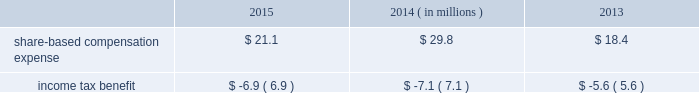During fiscal 2013 , we entered into an asr with a financial institution to repurchase an aggregate of $ 125 million of our common stock .
In exchange for an up-front payment of $ 125 million , the financial institution committed to deliver a number of shares during the asr 2019s purchase period , which ended on march 30 , 2013 .
The total number of shares delivered under this asr was 2.5 million at an average price of $ 49.13 per share .
During fiscal 2013 , in addition to shares repurchased under the asr , we repurchased and retired 1.1 million shares of our common stock at a cost of $ 50.3 million , or an average of $ 44.55 per share , including commissions .
Note 10 2014share-based awards and options non-qualified stock options and restricted stock have been granted to officers , key employees and directors under the global payments inc .
2000 long-term incentive plan , as amended and restated ( the 201c2000 plan 201d ) , the global payments inc .
Amended and restated 2005 incentive plan ( the 201c2005 plan 201d ) , the amended and restated 2000 non-employee director stock option plan ( the 201cdirector stock option plan 201d ) , and the global payments inc .
2011 incentive plan ( the 201c2011 plan 201d ) ( collectively , the 201cplans 201d ) .
There were no further grants made under the 2000 plan after the 2005 plan was effective , and the director stock option plan expired by its terms on february 1 , 2011 .
There will be no future grants under the 2000 plan , the 2005 plan or the director stock option the 2011 plan permits grants of equity to employees , officers , directors and consultants .
A total of 7.0 million shares of our common stock was reserved and made available for issuance pursuant to awards granted under the 2011 plan .
The table summarizes share-based compensation expense and the related income tax benefit recognized for stock options , restricted stock , performance units , tsr units , and shares issued under our employee stock purchase plan ( each as described below ) .
2015 2014 2013 ( in millions ) .
We grant various share-based awards pursuant to the plans under what we refer to as our 201clong-term incentive plan . 201d the awards are held in escrow and released upon the grantee 2019s satisfaction of conditions of the award certificate .
Restricted stock and restricted stock units we grant restricted stock and restricted stock units .
Restricted stock awards vest over a period of time , provided , however , that if the grantee is not employed by us on the vesting date , the shares are forfeited .
Restricted shares cannot be sold or transferred until they have vested .
Restricted stock granted before fiscal 2015 vests in equal installments on each of the first four anniversaries of the grant date .
Restricted stock granted during fiscal 2015 will either vest in equal installments on each of the first three anniversaries of the grant date or cliff vest at the end of a three-year service period .
The grant date fair value of restricted stock , which is based on the quoted market value of our common stock at the closing of the award date , is recognized as share-based compensation expense on a straight-line basis over the vesting period .
Performance units certain of our executives have been granted up to three types of performance units under our long-term incentive plan .
Performance units are performance-based restricted stock units that , after a performance period , convert into common shares , which may be restricted .
The number of shares is dependent upon the achievement of certain performance measures during the performance period .
The target number of performance units and any market-based performance measures ( 201cat threshold , 201d 201ctarget , 201d and 201cmaximum 201d ) are set by the compensation committee of our board of directors .
Performance units are converted only after the compensation committee certifies performance based on pre-established goals .
80 2013 global payments inc .
| 2015 form 10-k annual report .
What was the total income tax benefit that came from buying back their common stock from 2013 to 2015? 
Rationale: to calculate the income tax benefit one would need to add up the income tax benefit for the years of 2013 , 2014 , and 2015 .
Computations: (5.6 + (6.9 + 7.1))
Answer: 19.6. During fiscal 2013 , we entered into an asr with a financial institution to repurchase an aggregate of $ 125 million of our common stock .
In exchange for an up-front payment of $ 125 million , the financial institution committed to deliver a number of shares during the asr 2019s purchase period , which ended on march 30 , 2013 .
The total number of shares delivered under this asr was 2.5 million at an average price of $ 49.13 per share .
During fiscal 2013 , in addition to shares repurchased under the asr , we repurchased and retired 1.1 million shares of our common stock at a cost of $ 50.3 million , or an average of $ 44.55 per share , including commissions .
Note 10 2014share-based awards and options non-qualified stock options and restricted stock have been granted to officers , key employees and directors under the global payments inc .
2000 long-term incentive plan , as amended and restated ( the 201c2000 plan 201d ) , the global payments inc .
Amended and restated 2005 incentive plan ( the 201c2005 plan 201d ) , the amended and restated 2000 non-employee director stock option plan ( the 201cdirector stock option plan 201d ) , and the global payments inc .
2011 incentive plan ( the 201c2011 plan 201d ) ( collectively , the 201cplans 201d ) .
There were no further grants made under the 2000 plan after the 2005 plan was effective , and the director stock option plan expired by its terms on february 1 , 2011 .
There will be no future grants under the 2000 plan , the 2005 plan or the director stock option the 2011 plan permits grants of equity to employees , officers , directors and consultants .
A total of 7.0 million shares of our common stock was reserved and made available for issuance pursuant to awards granted under the 2011 plan .
The table summarizes share-based compensation expense and the related income tax benefit recognized for stock options , restricted stock , performance units , tsr units , and shares issued under our employee stock purchase plan ( each as described below ) .
2015 2014 2013 ( in millions ) .
We grant various share-based awards pursuant to the plans under what we refer to as our 201clong-term incentive plan . 201d the awards are held in escrow and released upon the grantee 2019s satisfaction of conditions of the award certificate .
Restricted stock and restricted stock units we grant restricted stock and restricted stock units .
Restricted stock awards vest over a period of time , provided , however , that if the grantee is not employed by us on the vesting date , the shares are forfeited .
Restricted shares cannot be sold or transferred until they have vested .
Restricted stock granted before fiscal 2015 vests in equal installments on each of the first four anniversaries of the grant date .
Restricted stock granted during fiscal 2015 will either vest in equal installments on each of the first three anniversaries of the grant date or cliff vest at the end of a three-year service period .
The grant date fair value of restricted stock , which is based on the quoted market value of our common stock at the closing of the award date , is recognized as share-based compensation expense on a straight-line basis over the vesting period .
Performance units certain of our executives have been granted up to three types of performance units under our long-term incentive plan .
Performance units are performance-based restricted stock units that , after a performance period , convert into common shares , which may be restricted .
The number of shares is dependent upon the achievement of certain performance measures during the performance period .
The target number of performance units and any market-based performance measures ( 201cat threshold , 201d 201ctarget , 201d and 201cmaximum 201d ) are set by the compensation committee of our board of directors .
Performance units are converted only after the compensation committee certifies performance based on pre-established goals .
80 2013 global payments inc .
| 2015 form 10-k annual report .
What is the effective income tax rate which generated the income tax benefit from the share-based expense in 2015? 
Computations: (6.9 / 21.1)
Answer: 0.32701. 